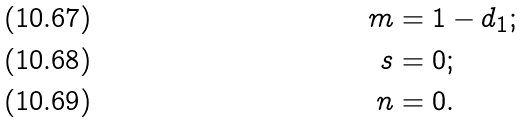<formula> <loc_0><loc_0><loc_500><loc_500>m & = 1 - d _ { 1 } ; \\ s & = 0 ; \\ n & = 0 .</formula> 